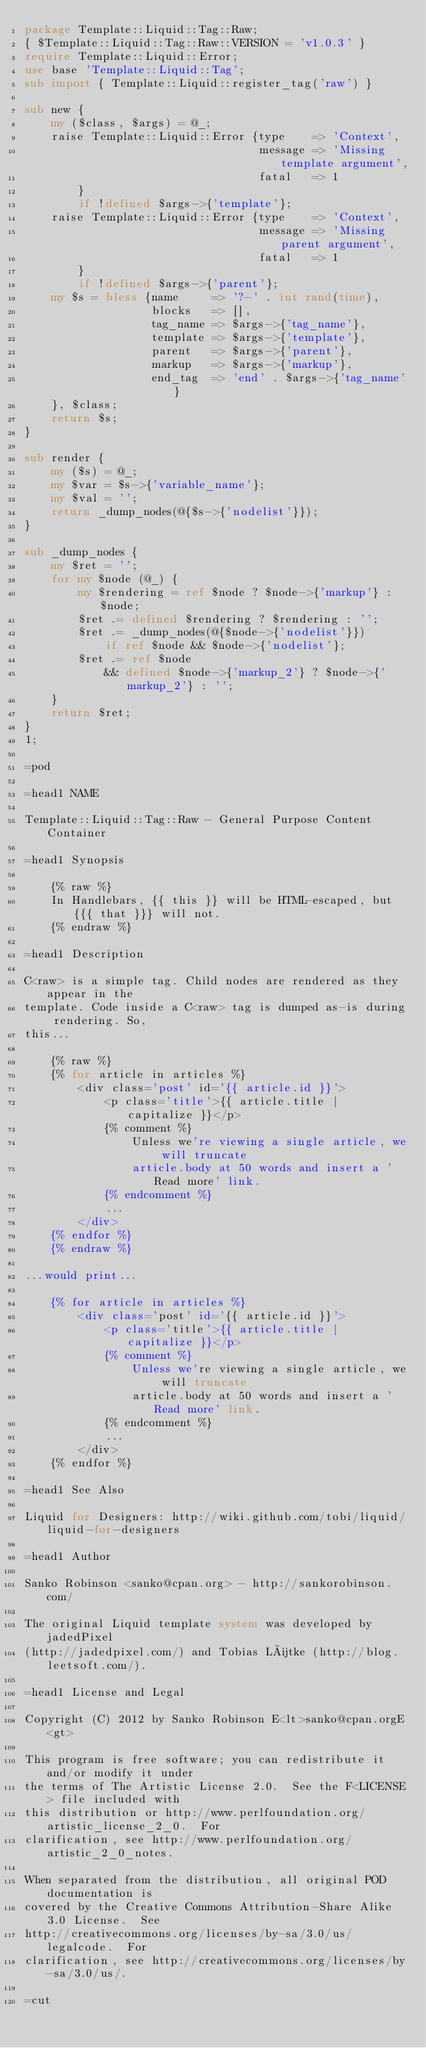<code> <loc_0><loc_0><loc_500><loc_500><_Perl_>package Template::Liquid::Tag::Raw;
{ $Template::Liquid::Tag::Raw::VERSION = 'v1.0.3' }
require Template::Liquid::Error;
use base 'Template::Liquid::Tag';
sub import { Template::Liquid::register_tag('raw') }

sub new {
    my ($class, $args) = @_;
    raise Template::Liquid::Error {type    => 'Context',
                                   message => 'Missing template argument',
                                   fatal   => 1
        }
        if !defined $args->{'template'};
    raise Template::Liquid::Error {type    => 'Context',
                                   message => 'Missing parent argument',
                                   fatal   => 1
        }
        if !defined $args->{'parent'};
    my $s = bless {name     => '?-' . int rand(time),
                   blocks   => [],
                   tag_name => $args->{'tag_name'},
                   template => $args->{'template'},
                   parent   => $args->{'parent'},
                   markup   => $args->{'markup'},
                   end_tag  => 'end' . $args->{'tag_name'}
    }, $class;
    return $s;
}

sub render {
    my ($s) = @_;
    my $var = $s->{'variable_name'};
    my $val = '';
    return _dump_nodes(@{$s->{'nodelist'}});
}

sub _dump_nodes {
    my $ret = '';
    for my $node (@_) {
        my $rendering = ref $node ? $node->{'markup'} : $node;
        $ret .= defined $rendering ? $rendering : '';
        $ret .= _dump_nodes(@{$node->{'nodelist'}})
            if ref $node && $node->{'nodelist'};
        $ret .= ref $node
            && defined $node->{'markup_2'} ? $node->{'markup_2'} : '';
    }
    return $ret;
}
1;

=pod

=head1 NAME

Template::Liquid::Tag::Raw - General Purpose Content Container

=head1 Synopsis

    {% raw %}
    In Handlebars, {{ this }} will be HTML-escaped, but {{{ that }}} will not.
    {% endraw %}

=head1 Description

C<raw> is a simple tag. Child nodes are rendered as they appear in the
template. Code inside a C<raw> tag is dumped as-is during rendering. So,
this...

    {% raw %}
    {% for article in articles %}
        <div class='post' id='{{ article.id }}'>
            <p class='title'>{{ article.title | capitalize }}</p>
            {% comment %}
                Unless we're viewing a single article, we will truncate
                article.body at 50 words and insert a 'Read more' link.
            {% endcomment %}
            ...
        </div>
    {% endfor %}
    {% endraw %}

...would print...

    {% for article in articles %}
        <div class='post' id='{{ article.id }}'>
            <p class='title'>{{ article.title | capitalize }}</p>
            {% comment %}
                Unless we're viewing a single article, we will truncate
                article.body at 50 words and insert a 'Read more' link.
            {% endcomment %}
            ...
        </div>
    {% endfor %}

=head1 See Also

Liquid for Designers: http://wiki.github.com/tobi/liquid/liquid-for-designers

=head1 Author

Sanko Robinson <sanko@cpan.org> - http://sankorobinson.com/

The original Liquid template system was developed by jadedPixel
(http://jadedpixel.com/) and Tobias Lütke (http://blog.leetsoft.com/).

=head1 License and Legal

Copyright (C) 2012 by Sanko Robinson E<lt>sanko@cpan.orgE<gt>

This program is free software; you can redistribute it and/or modify it under
the terms of The Artistic License 2.0.  See the F<LICENSE> file included with
this distribution or http://www.perlfoundation.org/artistic_license_2_0.  For
clarification, see http://www.perlfoundation.org/artistic_2_0_notes.

When separated from the distribution, all original POD documentation is
covered by the Creative Commons Attribution-Share Alike 3.0 License.  See
http://creativecommons.org/licenses/by-sa/3.0/us/legalcode.  For
clarification, see http://creativecommons.org/licenses/by-sa/3.0/us/.

=cut
</code> 